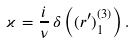Convert formula to latex. <formula><loc_0><loc_0><loc_500><loc_500>\varkappa = \frac { i } { \nu } \, \delta \left ( ( r ^ { \prime } ) ^ { ( 3 ) } _ { 1 } \right ) .</formula> 